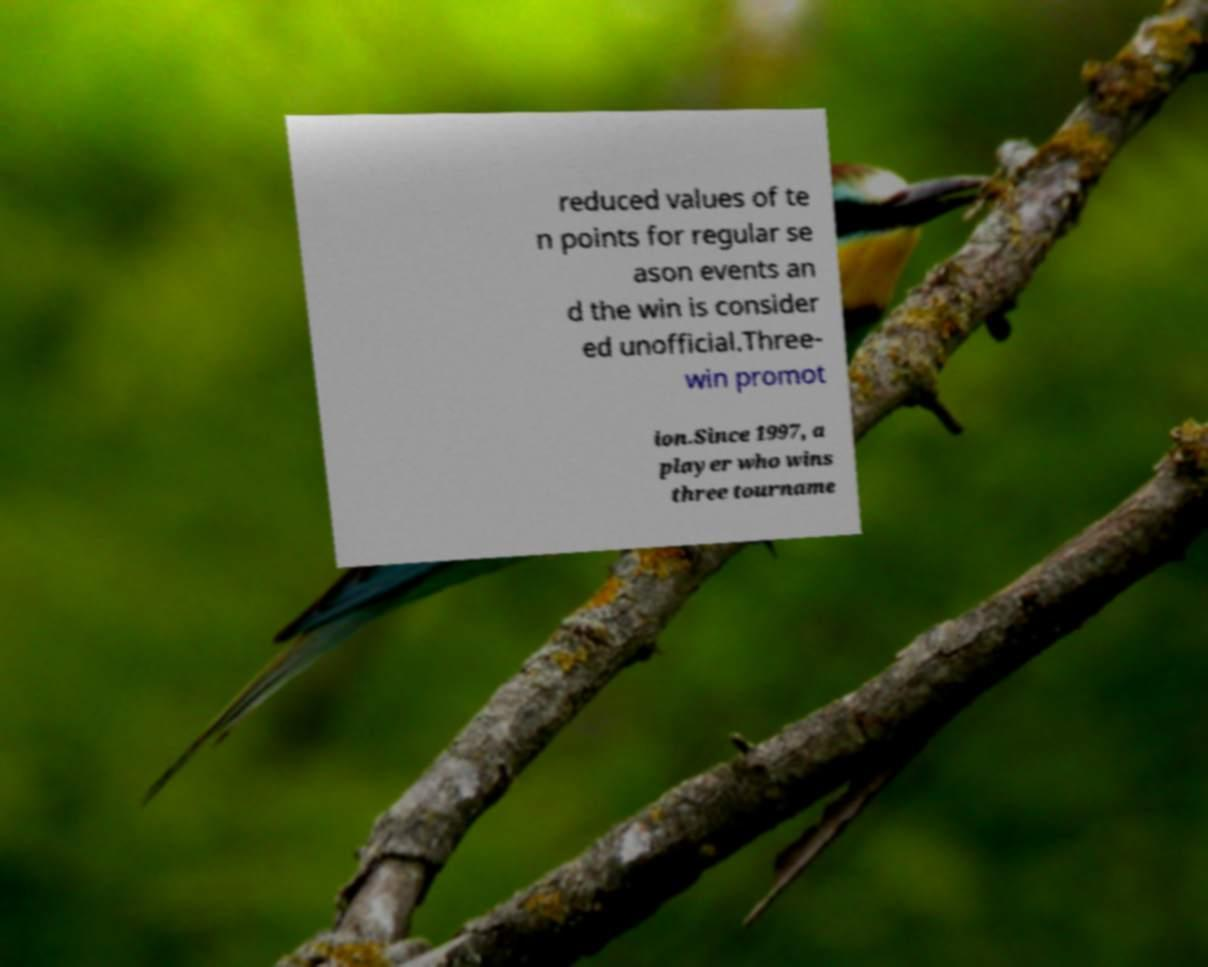Please identify and transcribe the text found in this image. reduced values of te n points for regular se ason events an d the win is consider ed unofficial.Three- win promot ion.Since 1997, a player who wins three tourname 